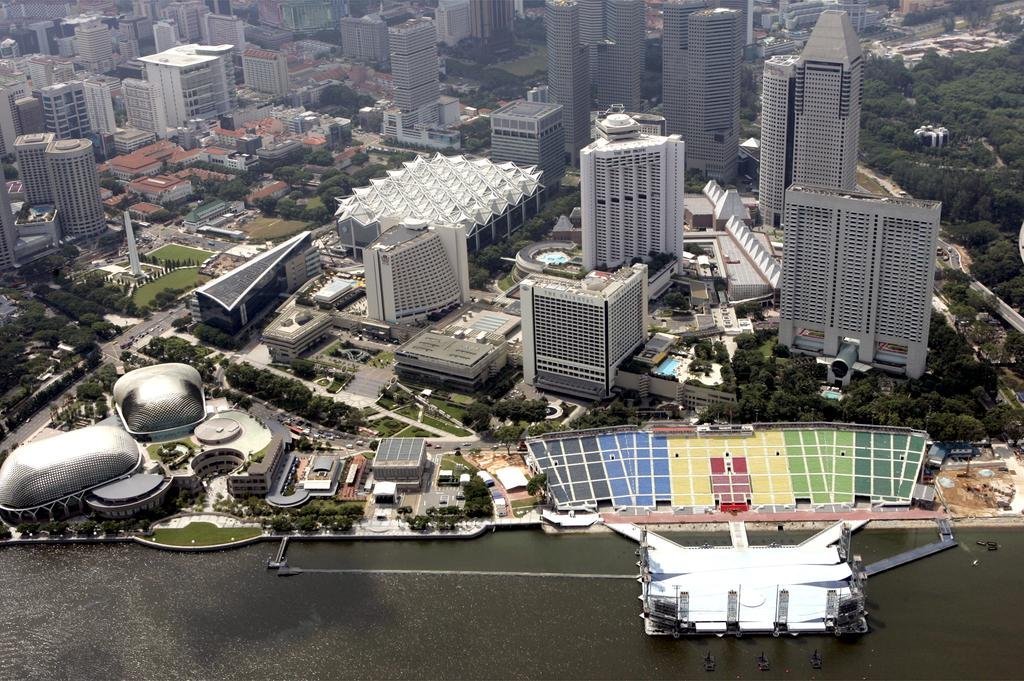What is the primary element present in the image? There is water in the image. What else can be seen in the image besides water? There are objects, buildings, trees, a road, vehicles, and grass in the image. Can you describe the type of environment depicted in the image? The image shows a combination of natural elements, such as trees and grass, and man-made structures, like buildings and roads. How many types of vehicles are visible in the image? There are vehicles in the image, but the specific number is not mentioned in the facts. What type of mitten is being worn by the bird in the image? There is no bird or mitten present in the image. What color is the cap on the tree in the image? There is no cap on any tree in the image. 